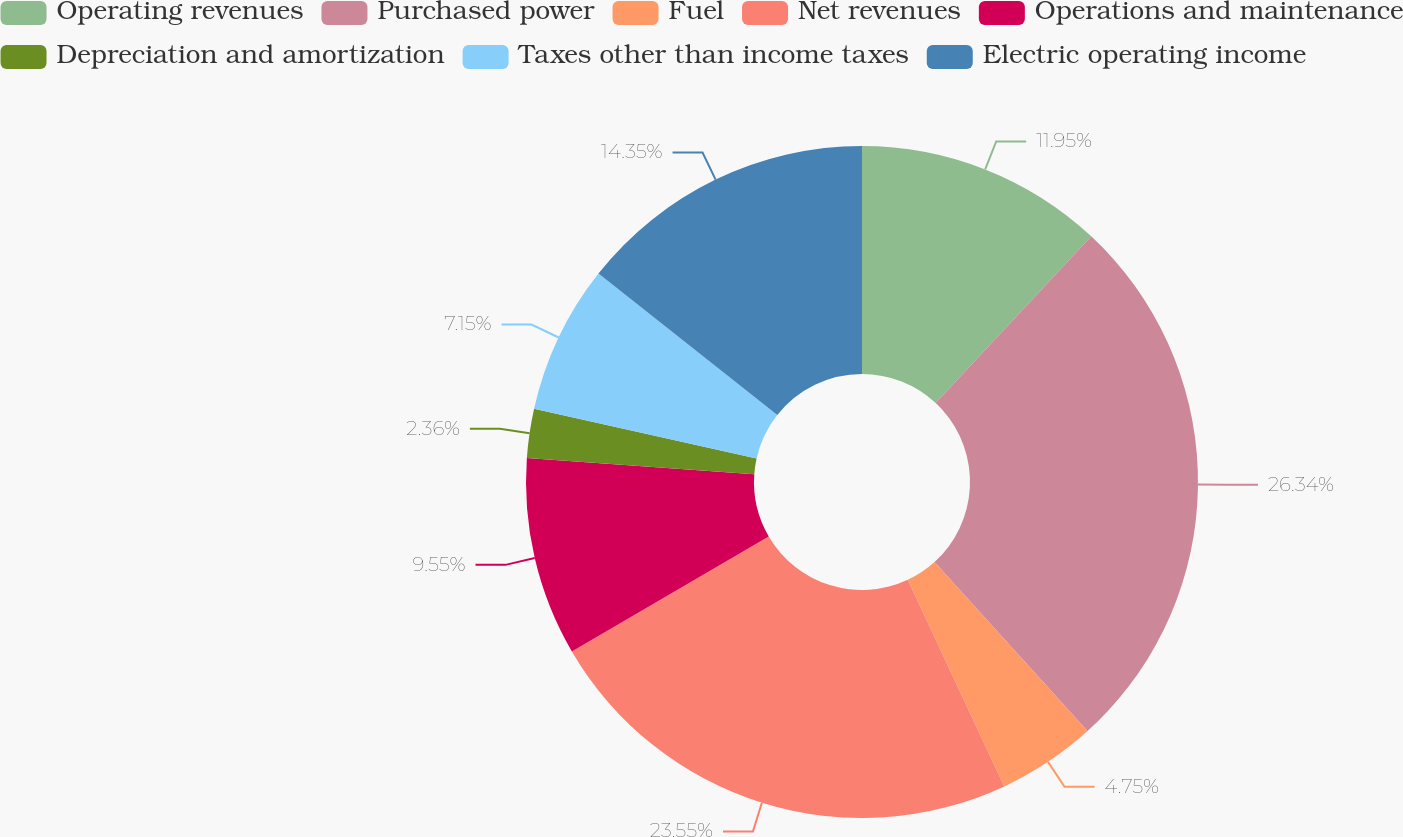<chart> <loc_0><loc_0><loc_500><loc_500><pie_chart><fcel>Operating revenues<fcel>Purchased power<fcel>Fuel<fcel>Net revenues<fcel>Operations and maintenance<fcel>Depreciation and amortization<fcel>Taxes other than income taxes<fcel>Electric operating income<nl><fcel>11.95%<fcel>26.34%<fcel>4.75%<fcel>23.55%<fcel>9.55%<fcel>2.36%<fcel>7.15%<fcel>14.35%<nl></chart> 